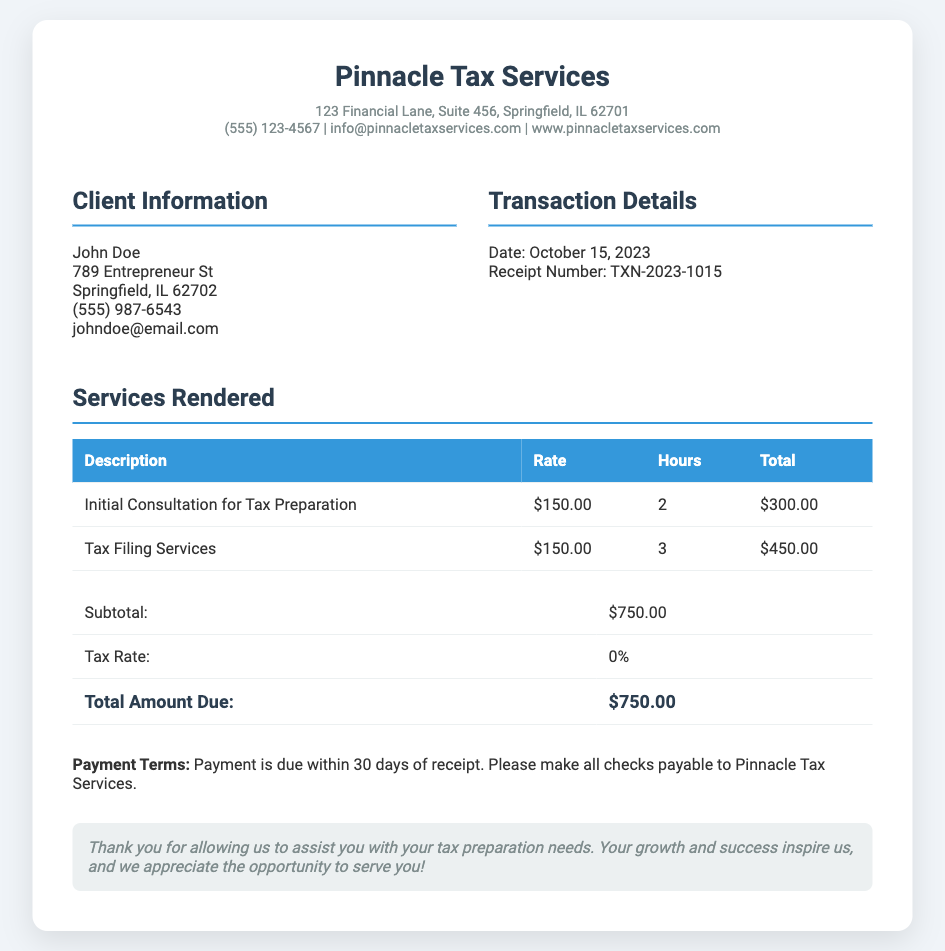What is the total amount due? The total amount due is clearly stated in the summary section of the document.
Answer: $750.00 What is the date of the transaction? The date of the transaction is noted in the transaction details section.
Answer: October 15, 2023 Who is the client? The client information section lists the individual receiving the services.
Answer: John Doe What services were rendered? The services rendered are categorized and listed in the services section of the document.
Answer: Initial Consultation for Tax Preparation, Tax Filing Services What was the hourly rate for the services? The hourly rate is listed next to each service in the services table.
Answer: $150.00 How many hours were spent on tax filing services? The number of hours is provided in the services table under tax filing services.
Answer: 3 How much was charged for the initial consultation? The charge is specified in the total column for the initial consultation row of the services table.
Answer: $300.00 What are the payment terms? The payment terms are mentioned near the end of the document.
Answer: Payment is due within 30 days of receipt What is the tax rate applied? The tax rate is indicated in the summary section of the document.
Answer: 0% 